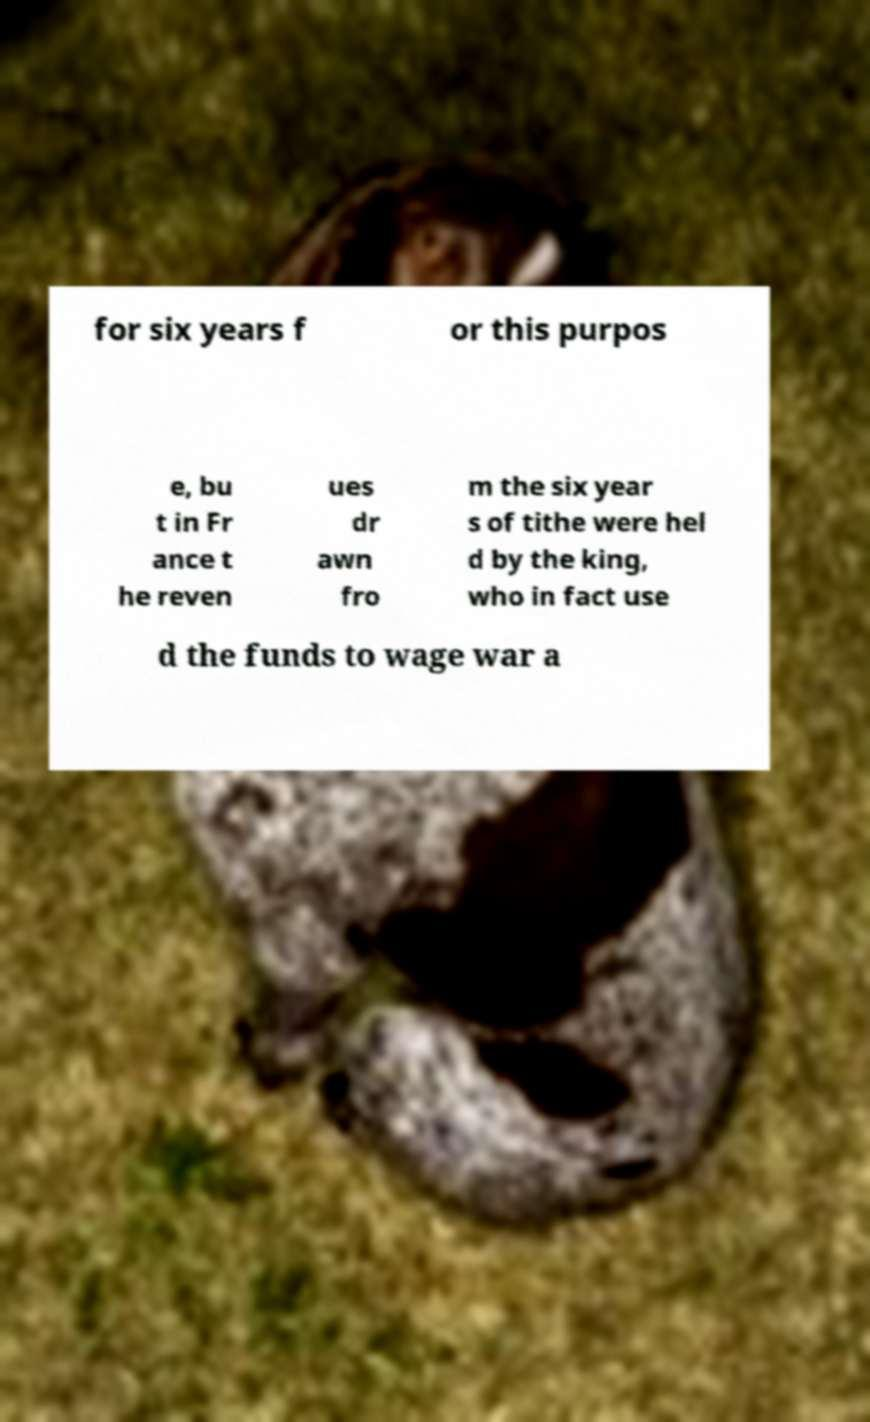Please identify and transcribe the text found in this image. for six years f or this purpos e, bu t in Fr ance t he reven ues dr awn fro m the six year s of tithe were hel d by the king, who in fact use d the funds to wage war a 